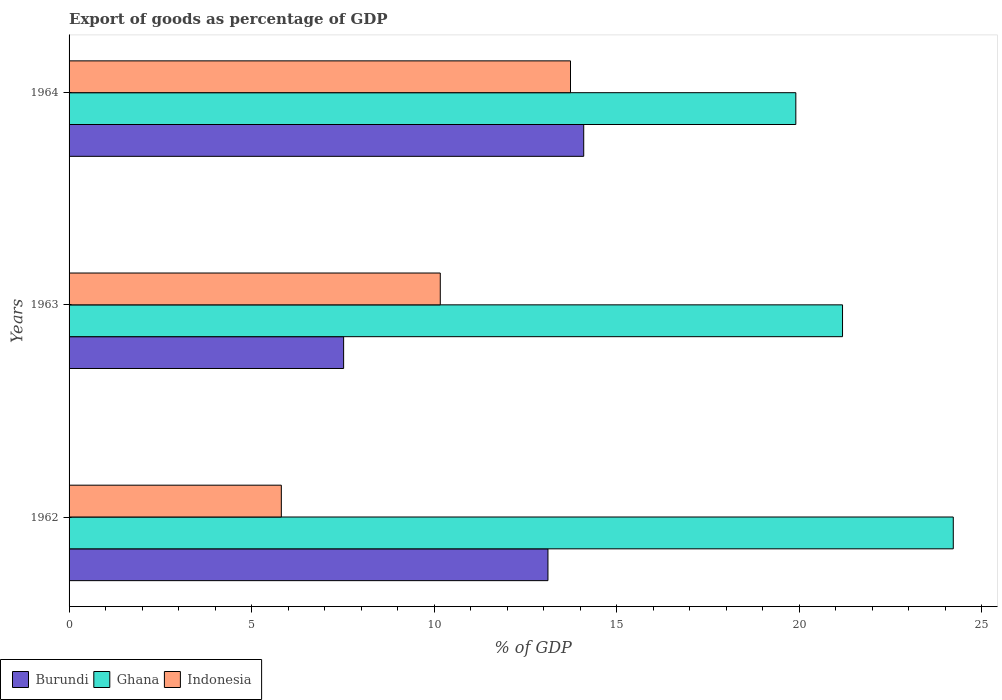How many different coloured bars are there?
Your response must be concise. 3. Are the number of bars on each tick of the Y-axis equal?
Offer a terse response. Yes. How many bars are there on the 2nd tick from the top?
Provide a succinct answer. 3. What is the label of the 1st group of bars from the top?
Offer a terse response. 1964. What is the export of goods as percentage of GDP in Burundi in 1962?
Make the answer very short. 13.11. Across all years, what is the maximum export of goods as percentage of GDP in Indonesia?
Keep it short and to the point. 13.73. Across all years, what is the minimum export of goods as percentage of GDP in Burundi?
Provide a short and direct response. 7.52. In which year was the export of goods as percentage of GDP in Burundi maximum?
Keep it short and to the point. 1964. In which year was the export of goods as percentage of GDP in Ghana minimum?
Your answer should be compact. 1964. What is the total export of goods as percentage of GDP in Indonesia in the graph?
Your response must be concise. 29.71. What is the difference between the export of goods as percentage of GDP in Ghana in 1963 and that in 1964?
Provide a short and direct response. 1.28. What is the difference between the export of goods as percentage of GDP in Ghana in 1964 and the export of goods as percentage of GDP in Burundi in 1962?
Offer a terse response. 6.79. What is the average export of goods as percentage of GDP in Indonesia per year?
Your response must be concise. 9.9. In the year 1962, what is the difference between the export of goods as percentage of GDP in Ghana and export of goods as percentage of GDP in Indonesia?
Make the answer very short. 18.4. What is the ratio of the export of goods as percentage of GDP in Ghana in 1962 to that in 1964?
Offer a terse response. 1.22. What is the difference between the highest and the second highest export of goods as percentage of GDP in Burundi?
Offer a terse response. 0.98. What is the difference between the highest and the lowest export of goods as percentage of GDP in Ghana?
Ensure brevity in your answer.  4.31. Is the sum of the export of goods as percentage of GDP in Burundi in 1963 and 1964 greater than the maximum export of goods as percentage of GDP in Indonesia across all years?
Provide a succinct answer. Yes. What does the 1st bar from the top in 1964 represents?
Keep it short and to the point. Indonesia. Is it the case that in every year, the sum of the export of goods as percentage of GDP in Indonesia and export of goods as percentage of GDP in Ghana is greater than the export of goods as percentage of GDP in Burundi?
Offer a very short reply. Yes. Are all the bars in the graph horizontal?
Your answer should be compact. Yes. How many years are there in the graph?
Keep it short and to the point. 3. Are the values on the major ticks of X-axis written in scientific E-notation?
Ensure brevity in your answer.  No. Does the graph contain any zero values?
Make the answer very short. No. Does the graph contain grids?
Offer a terse response. No. How many legend labels are there?
Give a very brief answer. 3. What is the title of the graph?
Your answer should be very brief. Export of goods as percentage of GDP. What is the label or title of the X-axis?
Your answer should be compact. % of GDP. What is the label or title of the Y-axis?
Offer a terse response. Years. What is the % of GDP of Burundi in 1962?
Provide a short and direct response. 13.11. What is the % of GDP in Ghana in 1962?
Your response must be concise. 24.21. What is the % of GDP in Indonesia in 1962?
Give a very brief answer. 5.81. What is the % of GDP of Burundi in 1963?
Give a very brief answer. 7.52. What is the % of GDP of Ghana in 1963?
Ensure brevity in your answer.  21.18. What is the % of GDP of Indonesia in 1963?
Provide a short and direct response. 10.17. What is the % of GDP of Burundi in 1964?
Ensure brevity in your answer.  14.09. What is the % of GDP of Ghana in 1964?
Your answer should be very brief. 19.9. What is the % of GDP of Indonesia in 1964?
Provide a short and direct response. 13.73. Across all years, what is the maximum % of GDP in Burundi?
Your answer should be very brief. 14.09. Across all years, what is the maximum % of GDP in Ghana?
Your answer should be compact. 24.21. Across all years, what is the maximum % of GDP of Indonesia?
Offer a very short reply. 13.73. Across all years, what is the minimum % of GDP of Burundi?
Make the answer very short. 7.52. Across all years, what is the minimum % of GDP in Ghana?
Offer a terse response. 19.9. Across all years, what is the minimum % of GDP in Indonesia?
Make the answer very short. 5.81. What is the total % of GDP in Burundi in the graph?
Keep it short and to the point. 34.73. What is the total % of GDP of Ghana in the graph?
Keep it short and to the point. 65.3. What is the total % of GDP in Indonesia in the graph?
Your response must be concise. 29.71. What is the difference between the % of GDP of Burundi in 1962 and that in 1963?
Ensure brevity in your answer.  5.6. What is the difference between the % of GDP of Ghana in 1962 and that in 1963?
Your answer should be compact. 3.03. What is the difference between the % of GDP of Indonesia in 1962 and that in 1963?
Provide a short and direct response. -4.35. What is the difference between the % of GDP in Burundi in 1962 and that in 1964?
Provide a succinct answer. -0.98. What is the difference between the % of GDP of Ghana in 1962 and that in 1964?
Provide a succinct answer. 4.31. What is the difference between the % of GDP of Indonesia in 1962 and that in 1964?
Offer a very short reply. -7.92. What is the difference between the % of GDP of Burundi in 1963 and that in 1964?
Ensure brevity in your answer.  -6.58. What is the difference between the % of GDP of Ghana in 1963 and that in 1964?
Your response must be concise. 1.28. What is the difference between the % of GDP of Indonesia in 1963 and that in 1964?
Offer a very short reply. -3.57. What is the difference between the % of GDP of Burundi in 1962 and the % of GDP of Ghana in 1963?
Keep it short and to the point. -8.07. What is the difference between the % of GDP in Burundi in 1962 and the % of GDP in Indonesia in 1963?
Offer a terse response. 2.95. What is the difference between the % of GDP of Ghana in 1962 and the % of GDP of Indonesia in 1963?
Give a very brief answer. 14.05. What is the difference between the % of GDP of Burundi in 1962 and the % of GDP of Ghana in 1964?
Ensure brevity in your answer.  -6.79. What is the difference between the % of GDP of Burundi in 1962 and the % of GDP of Indonesia in 1964?
Ensure brevity in your answer.  -0.62. What is the difference between the % of GDP in Ghana in 1962 and the % of GDP in Indonesia in 1964?
Provide a succinct answer. 10.48. What is the difference between the % of GDP of Burundi in 1963 and the % of GDP of Ghana in 1964?
Your response must be concise. -12.38. What is the difference between the % of GDP of Burundi in 1963 and the % of GDP of Indonesia in 1964?
Provide a short and direct response. -6.21. What is the difference between the % of GDP of Ghana in 1963 and the % of GDP of Indonesia in 1964?
Offer a terse response. 7.45. What is the average % of GDP of Burundi per year?
Provide a short and direct response. 11.58. What is the average % of GDP of Ghana per year?
Provide a short and direct response. 21.77. What is the average % of GDP in Indonesia per year?
Provide a short and direct response. 9.9. In the year 1962, what is the difference between the % of GDP of Burundi and % of GDP of Indonesia?
Provide a succinct answer. 7.3. In the year 1962, what is the difference between the % of GDP of Ghana and % of GDP of Indonesia?
Your response must be concise. 18.4. In the year 1963, what is the difference between the % of GDP of Burundi and % of GDP of Ghana?
Your answer should be very brief. -13.66. In the year 1963, what is the difference between the % of GDP in Burundi and % of GDP in Indonesia?
Your response must be concise. -2.65. In the year 1963, what is the difference between the % of GDP of Ghana and % of GDP of Indonesia?
Ensure brevity in your answer.  11.02. In the year 1964, what is the difference between the % of GDP in Burundi and % of GDP in Ghana?
Make the answer very short. -5.81. In the year 1964, what is the difference between the % of GDP of Burundi and % of GDP of Indonesia?
Ensure brevity in your answer.  0.36. In the year 1964, what is the difference between the % of GDP of Ghana and % of GDP of Indonesia?
Your answer should be compact. 6.17. What is the ratio of the % of GDP in Burundi in 1962 to that in 1963?
Your answer should be very brief. 1.74. What is the ratio of the % of GDP in Ghana in 1962 to that in 1963?
Provide a short and direct response. 1.14. What is the ratio of the % of GDP of Indonesia in 1962 to that in 1963?
Your answer should be very brief. 0.57. What is the ratio of the % of GDP in Burundi in 1962 to that in 1964?
Provide a succinct answer. 0.93. What is the ratio of the % of GDP in Ghana in 1962 to that in 1964?
Your response must be concise. 1.22. What is the ratio of the % of GDP in Indonesia in 1962 to that in 1964?
Make the answer very short. 0.42. What is the ratio of the % of GDP in Burundi in 1963 to that in 1964?
Your response must be concise. 0.53. What is the ratio of the % of GDP of Ghana in 1963 to that in 1964?
Your response must be concise. 1.06. What is the ratio of the % of GDP of Indonesia in 1963 to that in 1964?
Make the answer very short. 0.74. What is the difference between the highest and the second highest % of GDP in Burundi?
Offer a terse response. 0.98. What is the difference between the highest and the second highest % of GDP in Ghana?
Offer a terse response. 3.03. What is the difference between the highest and the second highest % of GDP of Indonesia?
Provide a succinct answer. 3.57. What is the difference between the highest and the lowest % of GDP in Burundi?
Your answer should be very brief. 6.58. What is the difference between the highest and the lowest % of GDP in Ghana?
Keep it short and to the point. 4.31. What is the difference between the highest and the lowest % of GDP of Indonesia?
Your answer should be very brief. 7.92. 